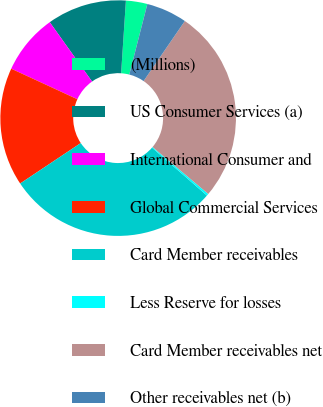Convert chart. <chart><loc_0><loc_0><loc_500><loc_500><pie_chart><fcel>(Millions)<fcel>US Consumer Services (a)<fcel>International Consumer and<fcel>Global Commercial Services<fcel>Card Member receivables<fcel>Less Reserve for losses<fcel>Card Member receivables net<fcel>Other receivables net (b)<nl><fcel>2.94%<fcel>10.91%<fcel>8.25%<fcel>16.26%<fcel>29.22%<fcel>0.28%<fcel>26.56%<fcel>5.59%<nl></chart> 